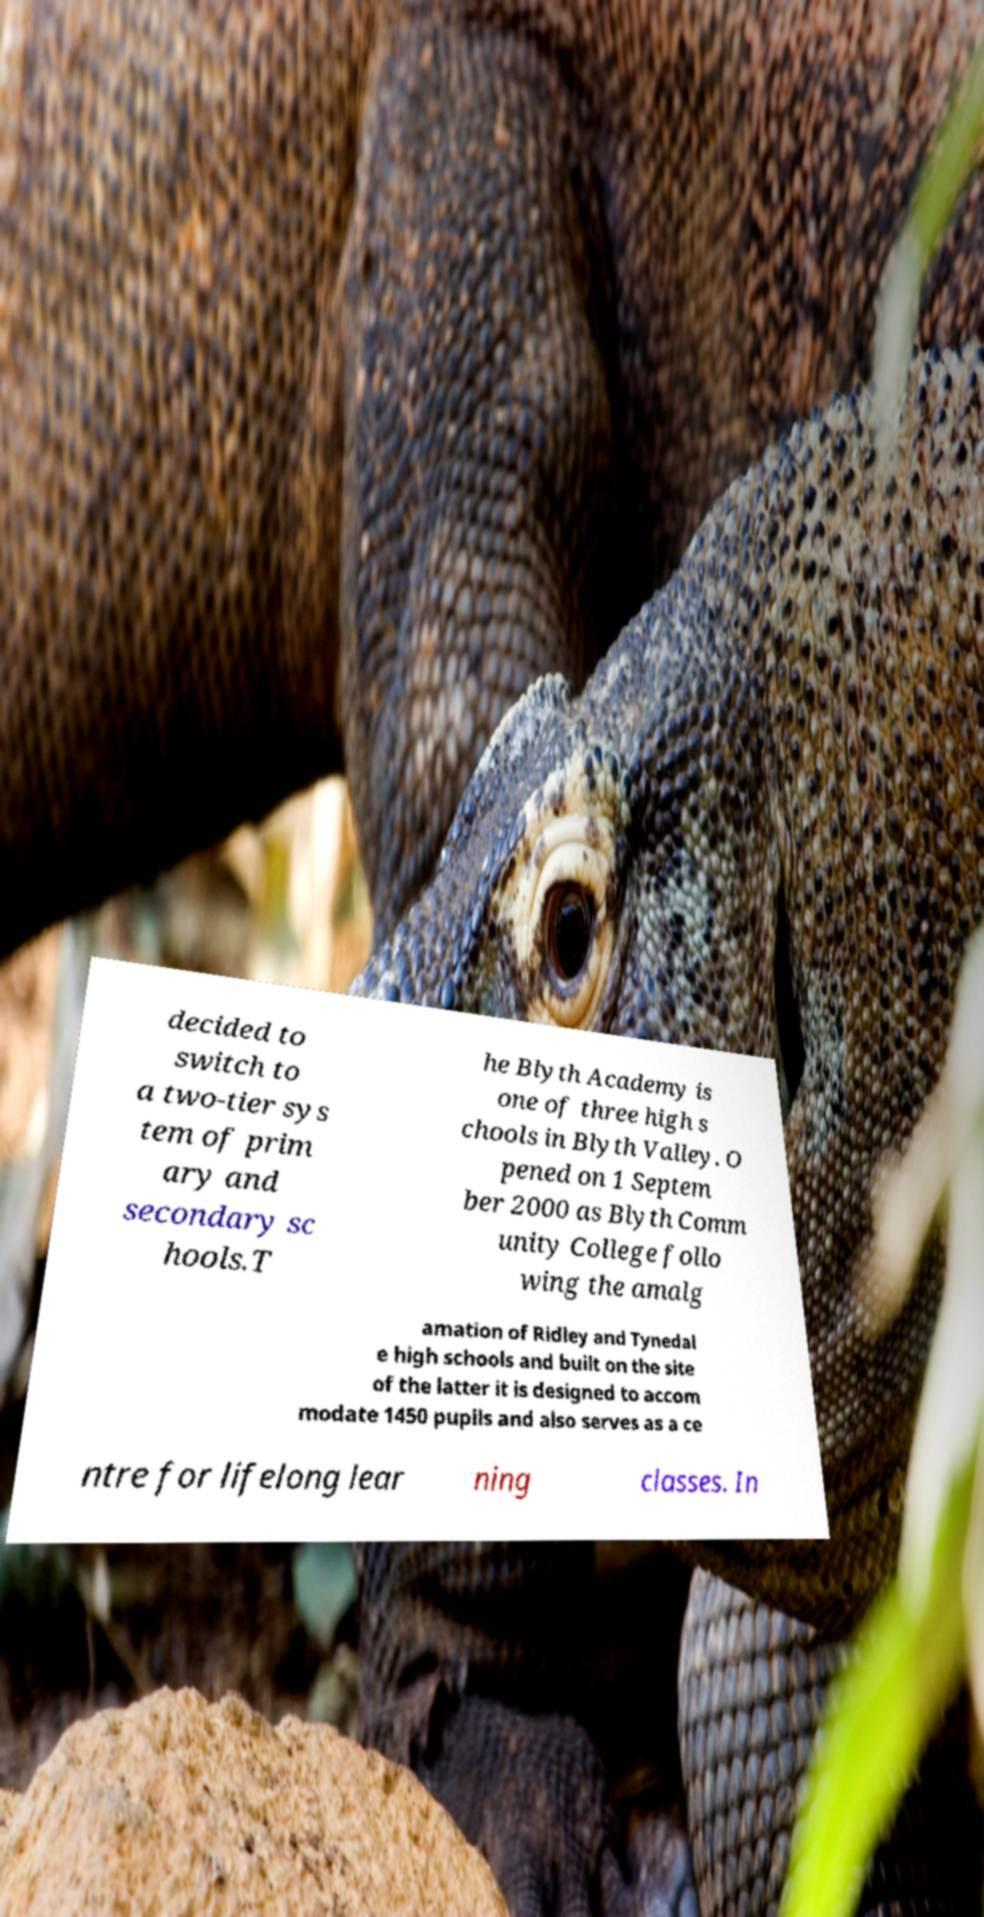Can you accurately transcribe the text from the provided image for me? decided to switch to a two-tier sys tem of prim ary and secondary sc hools.T he Blyth Academy is one of three high s chools in Blyth Valley. O pened on 1 Septem ber 2000 as Blyth Comm unity College follo wing the amalg amation of Ridley and Tynedal e high schools and built on the site of the latter it is designed to accom modate 1450 pupils and also serves as a ce ntre for lifelong lear ning classes. In 